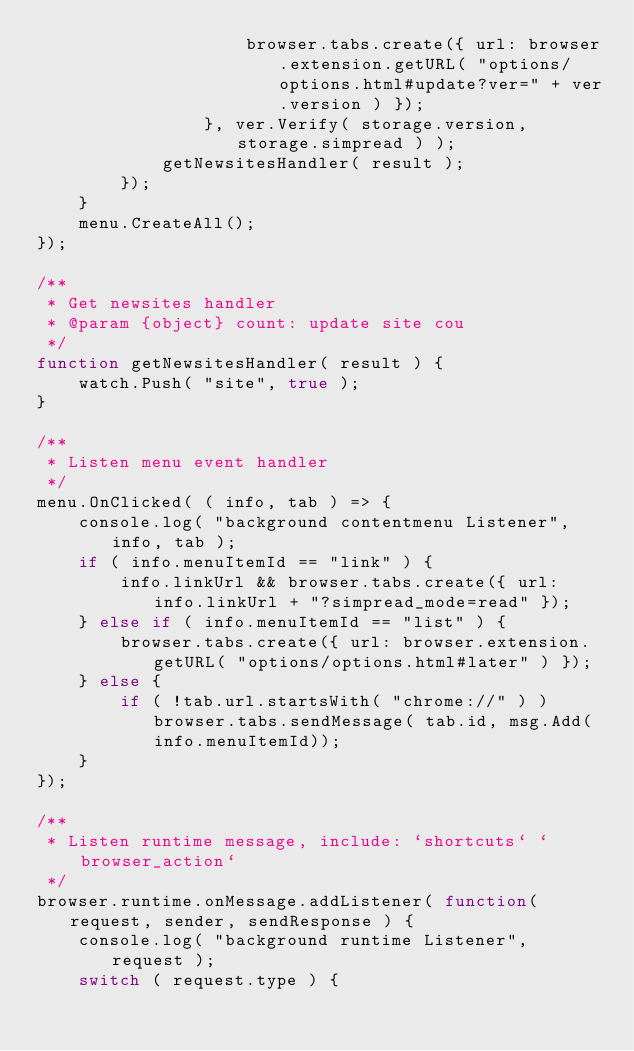<code> <loc_0><loc_0><loc_500><loc_500><_JavaScript_>                    browser.tabs.create({ url: browser.extension.getURL( "options/options.html#update?ver=" + ver.version ) });
                }, ver.Verify( storage.version, storage.simpread ) );
            getNewsitesHandler( result );
        });
    }
    menu.CreateAll();
});

/**
 * Get newsites handler
 * @param {object} count: update site cou
 */
function getNewsitesHandler( result ) {
    watch.Push( "site", true );
}

/**
 * Listen menu event handler
 */
menu.OnClicked( ( info, tab ) => {
    console.log( "background contentmenu Listener", info, tab );
    if ( info.menuItemId == "link" ) {
        info.linkUrl && browser.tabs.create({ url: info.linkUrl + "?simpread_mode=read" });
    } else if ( info.menuItemId == "list" ) {
        browser.tabs.create({ url: browser.extension.getURL( "options/options.html#later" ) });
    } else {
        if ( !tab.url.startsWith( "chrome://" ) ) browser.tabs.sendMessage( tab.id, msg.Add(info.menuItemId));
    }
});

/**
 * Listen runtime message, include: `shortcuts` `browser_action`
 */
browser.runtime.onMessage.addListener( function( request, sender, sendResponse ) {
    console.log( "background runtime Listener", request );
    switch ( request.type ) {</code> 